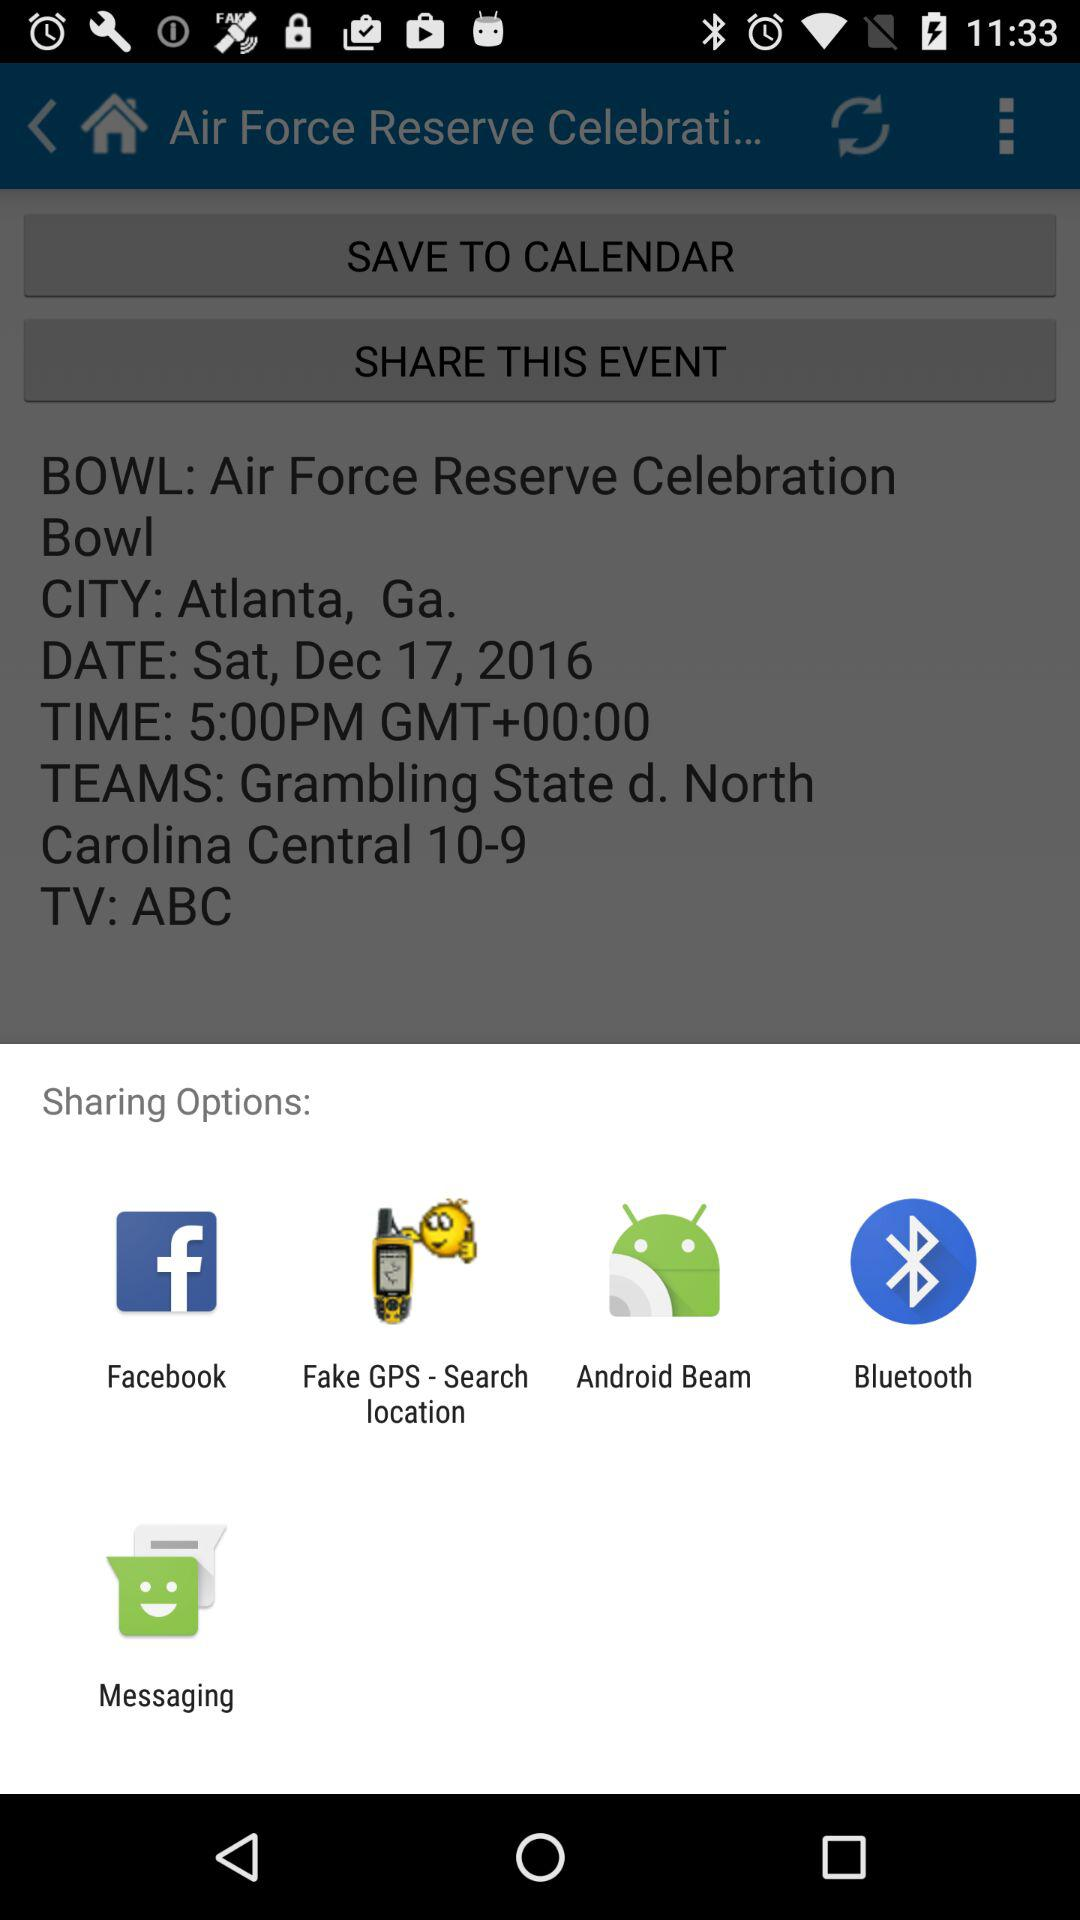What is the date of the event? The date of the event is Saturday, December 17, 2016. 